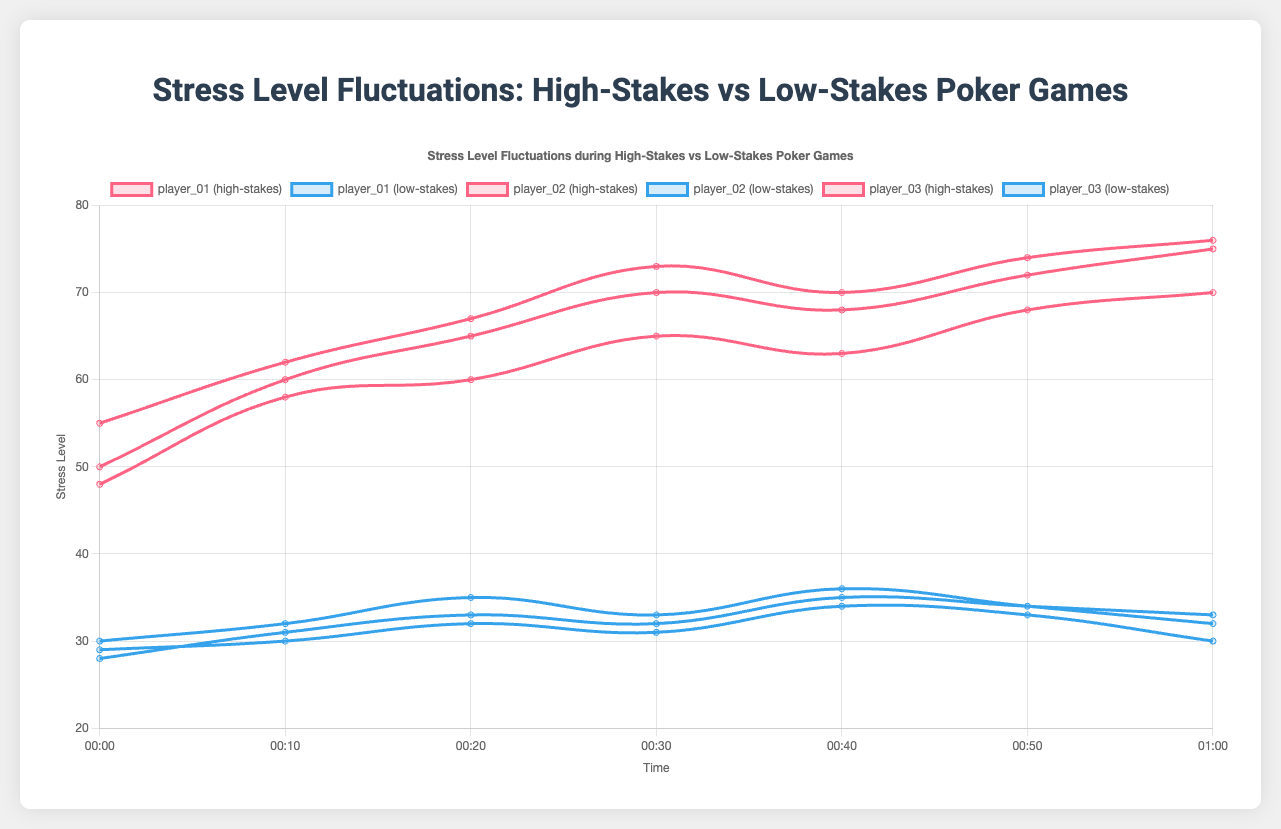What's the average peak stress level for high-stakes games across all players? For each player, identify the highest stress level during the high-stakes sessions: (player_01: 75, player_02: 76, player_03: 70). Sum these values and divide by the number of players: (75 + 76 + 70) / 3 = 221 / 3 ≈ 73.7
Answer: 73.7 Which player had the highest initial stress level during high-stakes games? Examine the first stress level reading for high-stakes sessions for each player: player_01 (50), player_02 (55), player_03 (48). The highest value is 55, recorded by player_02
Answer: player_02 How does the highest stress level in low-stakes compare to the highest stress level in high-stakes for player_03? Player_03’s highest stress level in low-stakes is 34. In high-stakes, it is 70. Comparing these, 70 (high-stakes) is greater than 34 (low-stakes)
Answer: High-stakes > Low-stakes For which player does the stress level decrease the most in the last 10 minutes of a high-stakes game? Check the stress levels from 00:50 to 01:00 for each player during high-stakes: player_01 (72 to 75), player_02 (74 to 76), player_03 (68 to 70). All players show an increase rather than a decrease.
Answer: None Which session type generally exhibits a more stable (less fluctuating) stress level for player_01? Compare the stress level differences over time between high-stakes and low-stakes for player_01. High-stakes values are (50, 60, 65, 70, 68, 72, 75) and low-stakes values are (30, 32, 35, 33, 36, 34, 32). Low-stakes have smaller changes between points, indicating more stability.
Answer: Low-stakes What is the difference in average stress level between high-stakes and low-stakes games for player_02? Calculate the average for high-stakes: (55 + 62 + 67 + 73 + 70 + 74 + 76) / 7 ≈ 68.1. For low-stakes: (28 + 31 + 33 + 32 + 35 + 34 + 33) / 7 ≈ 32.3. The difference is 68.1 - 32.3 ≈ 35.8
Answer: 35.8 At what time during low-stakes games do we see the highest spike in stress level for player_03? Examine the stress levels of player_03 during low-stakes: (29, 30, 32, 31, 34, 33, 30). The highest spike occurs from 00:30 (31) to 00:40 (34).
Answer: 00:40 Which player exhibits the smallest change in stress level during their high-stakes session? Calculate the range for each player: 
- player_01: max 75 - min 50 = 25 
- player_02: max 76 - min 55 = 21 
- player_03: max 70 - min 48 = 22 
Player_02 has the smallest change: 21.
Answer: player_02 